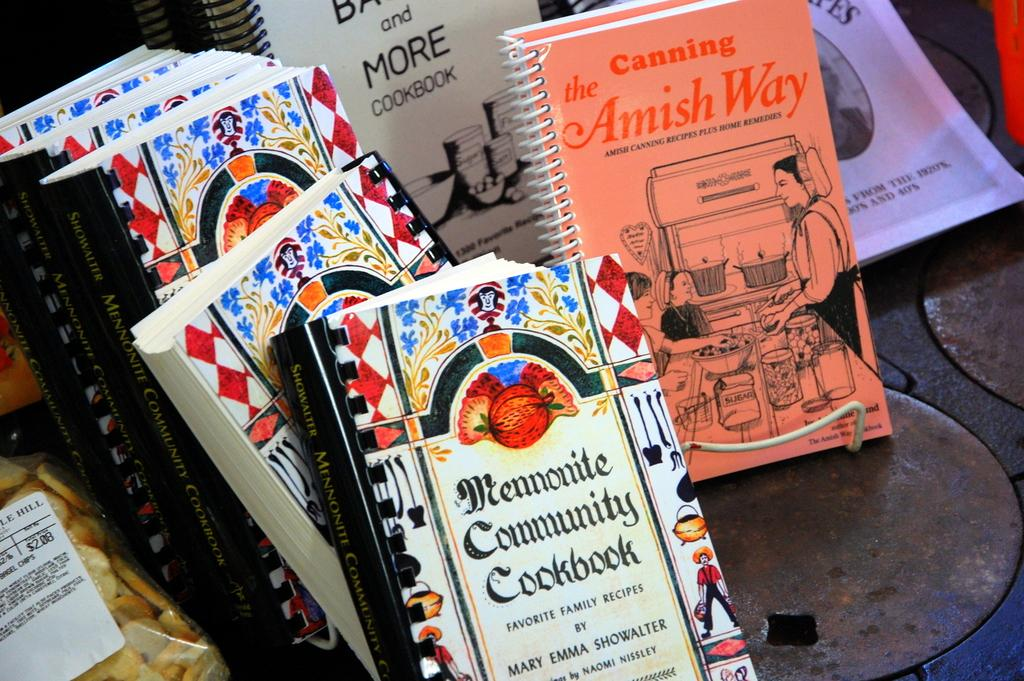<image>
Summarize the visual content of the image. A collection of books including a book named the amish way. 